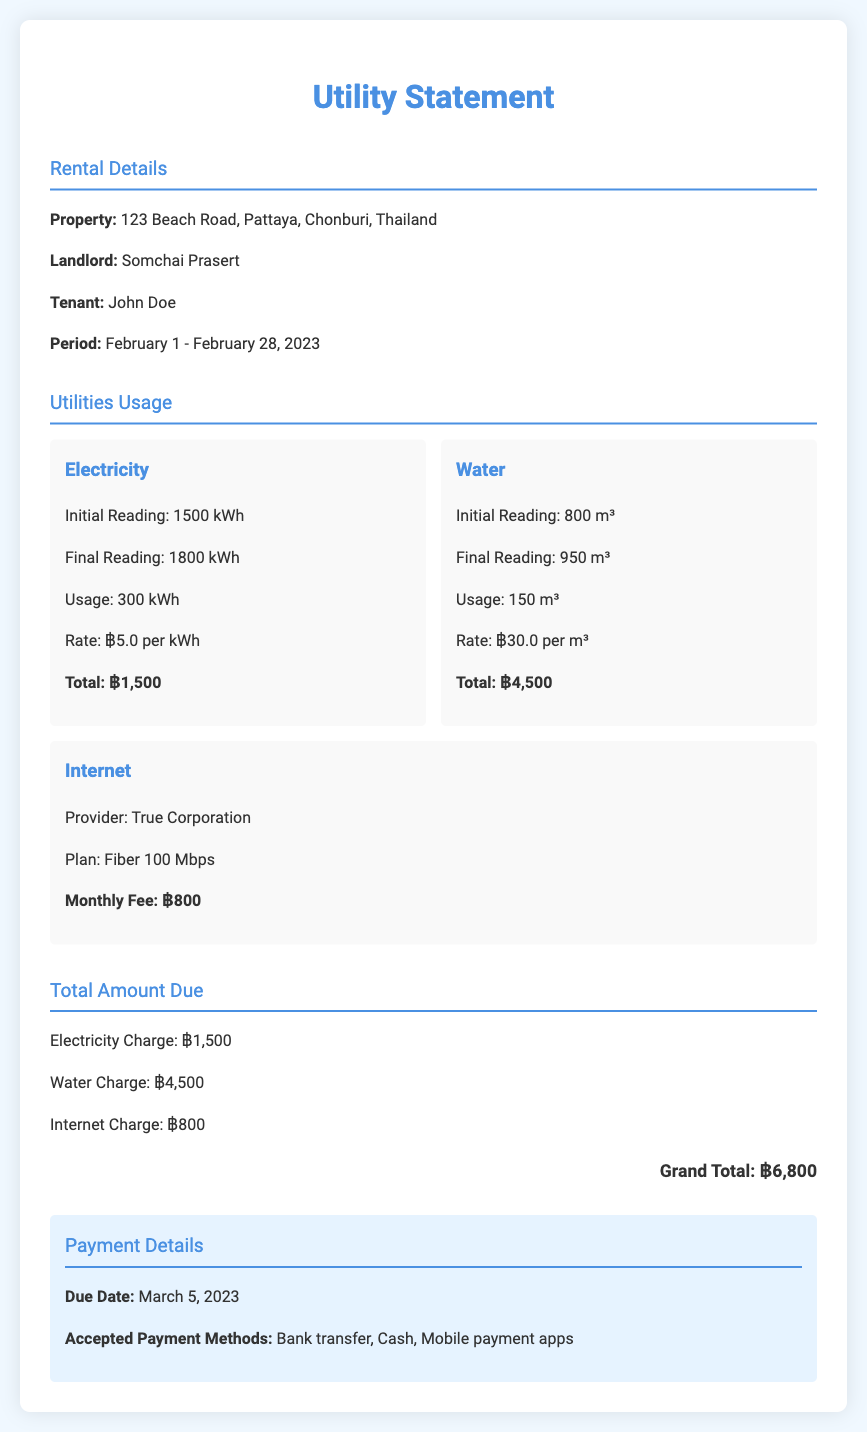What is the total amount due? The grand total due for the utilities in February 2023 is clearly stated in the document.
Answer: ฿6,800 Who is the landlord? The document specifies the landlord's name under the rental details section.
Answer: Somchai Prasert What is the electricity usage in kWh? The usage is calculated as the difference between the initial and final electricity readings provided in the utilities section.
Answer: 300 kWh What is the water charge? The total water charge is detailed under the utilities usage section.
Answer: ฿4,500 What is the internet provider's name? The internet provider is mentioned in the internet section of the document.
Answer: True Corporation What is the rate per kWh for electricity? The rate is specified next to the electricity usage information in the document.
Answer: ฿5.0 per kWh What is the monthly fee for the internet? The internet fee is presented in the internet section and is highlighted as the monthly fee.
Answer: ฿800 What is the due date for the payment? The due date is listed in the payment details section of the document.
Answer: March 5, 2023 What is the initial electricity reading? The initial reading is stated along with the final reading in the electricity usage section.
Answer: 1500 kWh 